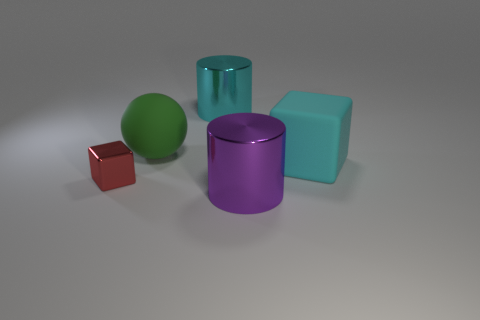Is the number of big purple metallic cylinders right of the large cyan matte thing less than the number of rubber cubes?
Your response must be concise. Yes. How many large objects have the same color as the large rubber cube?
Provide a short and direct response. 1. The object that is both to the left of the big purple cylinder and on the right side of the big green sphere is made of what material?
Provide a short and direct response. Metal. There is a cube that is right of the cyan cylinder; is its color the same as the big metallic object behind the small red shiny cube?
Your answer should be very brief. Yes. How many green things are either large matte spheres or metallic cubes?
Give a very brief answer. 1. Are there fewer metallic cylinders behind the large purple metal cylinder than big objects on the right side of the sphere?
Your answer should be compact. Yes. Are there any cyan objects of the same size as the cyan shiny cylinder?
Offer a terse response. Yes. There is a metal thing behind the green thing; is its size the same as the big cyan rubber object?
Provide a short and direct response. Yes. Are there more small rubber cubes than big cubes?
Ensure brevity in your answer.  No. Are there any gray matte things of the same shape as the large purple object?
Make the answer very short. No. 